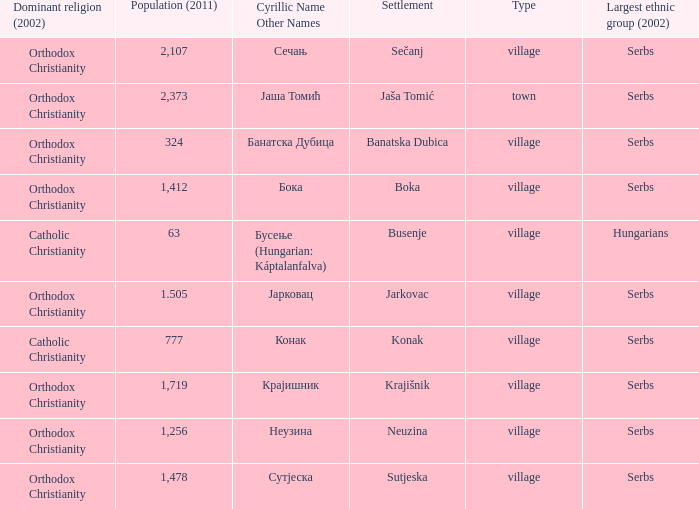What town has the population of 777? Конак. 